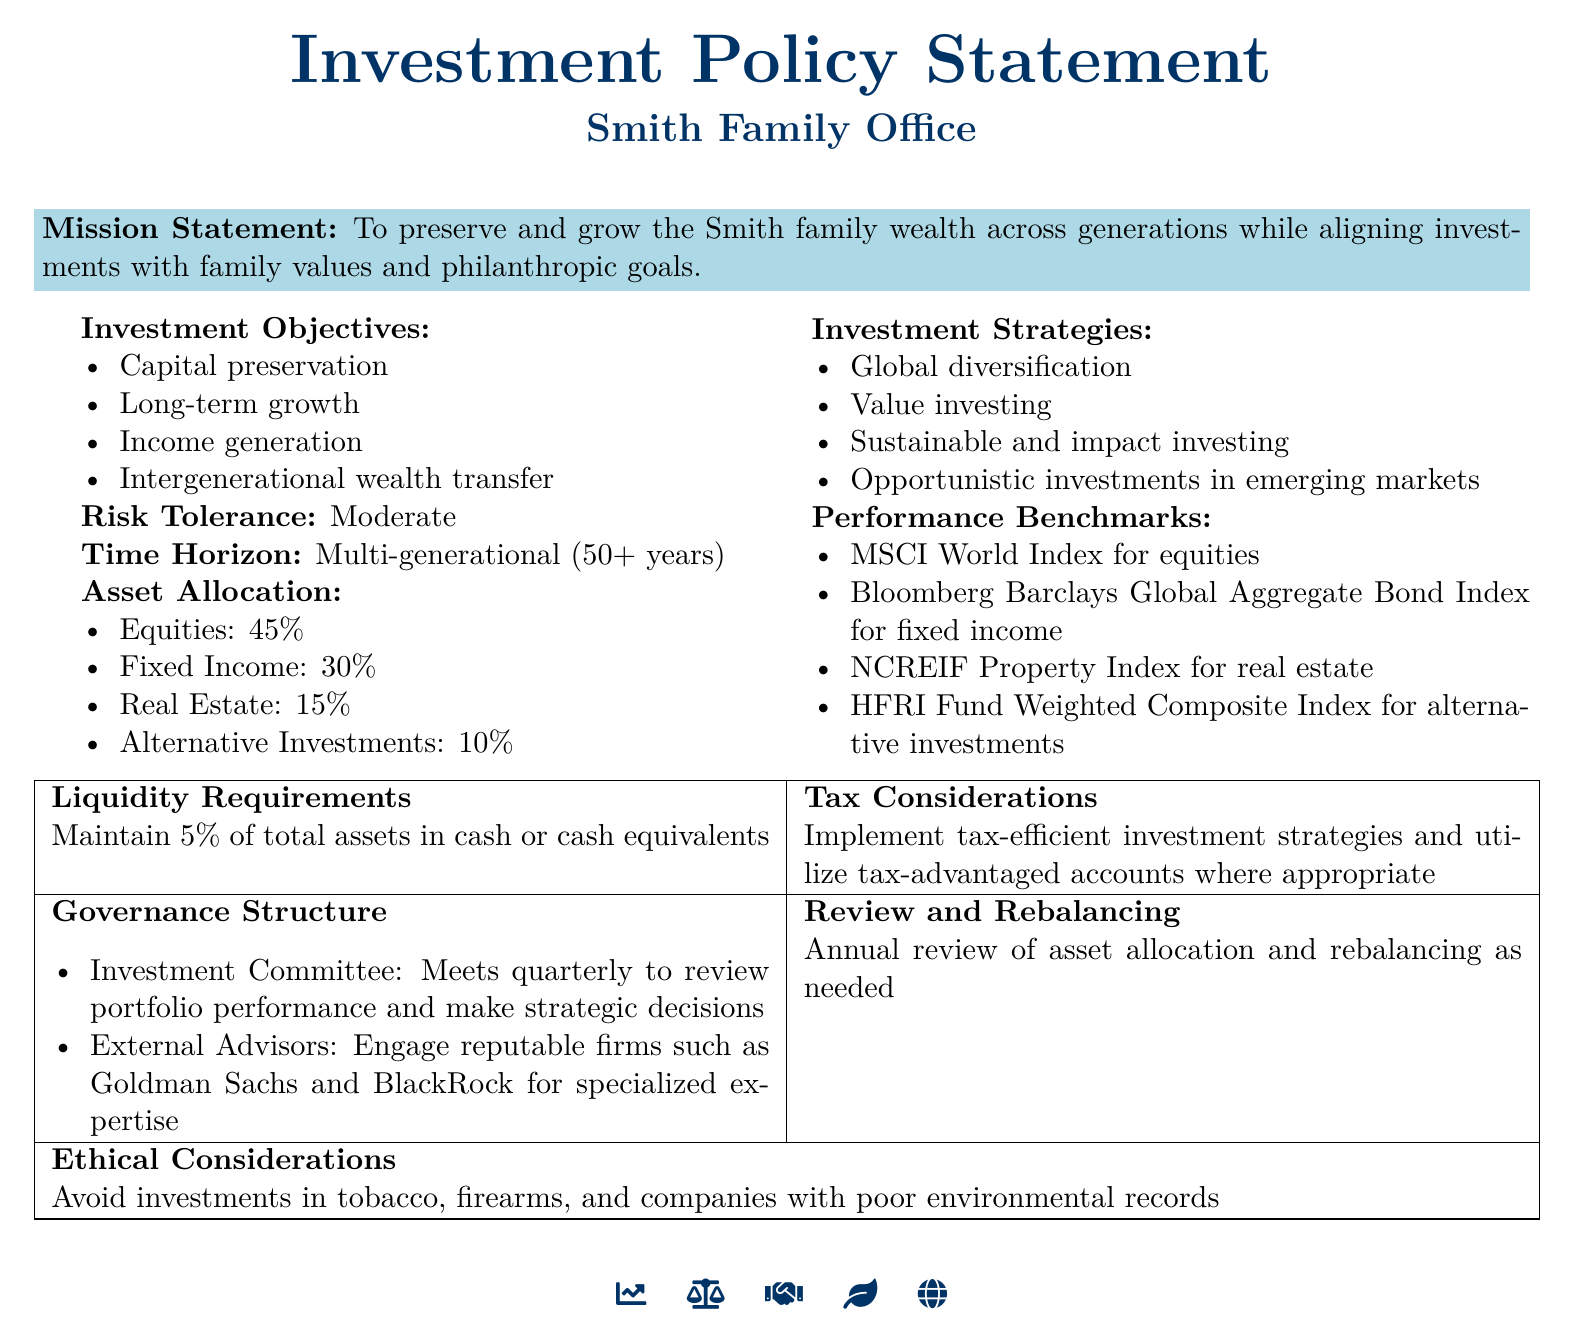What is the mission statement of the Smith Family Office? The mission statement outlines the goal of preserving and growing wealth across generations while aligning investments with family values and philanthropic goals.
Answer: To preserve and grow the Smith family wealth across generations while aligning investments with family values and philanthropic goals What is the risk tolerance indicated in the document? The document specifies the risk tolerance level suitable for the Smith Family Office's investment strategy.
Answer: Moderate What percentage of the asset allocation is dedicated to fixed income? The document provides specific asset allocation percentages for various investment categories.
Answer: 30% What is the time horizon for investments mentioned in the document? The time horizon provides insight into the duration for which the family office plans to invest.
Answer: Multi-generational (50+ years) Which index is used as a benchmark for alternative investments? The document states the performance benchmarks for different asset classes.
Answer: HFRI Fund Weighted Composite Index What type of investing is emphasized in the investment strategies? The document lists specific strategies that align with the family's investment goals.
Answer: Sustainable and impact investing How often does the Investment Committee meet? The governance structure details the frequency of meetings for oversight and strategy evaluation.
Answer: Quarterly What is maintained as a liquidity requirement? The document specifies a requirement related to liquidity management for the family office.
Answer: 5% of total assets in cash or cash equivalents Which two firms are mentioned as external advisors? The document names reputable firms that provide specialized expertise for investment management.
Answer: Goldman Sachs and BlackRock 